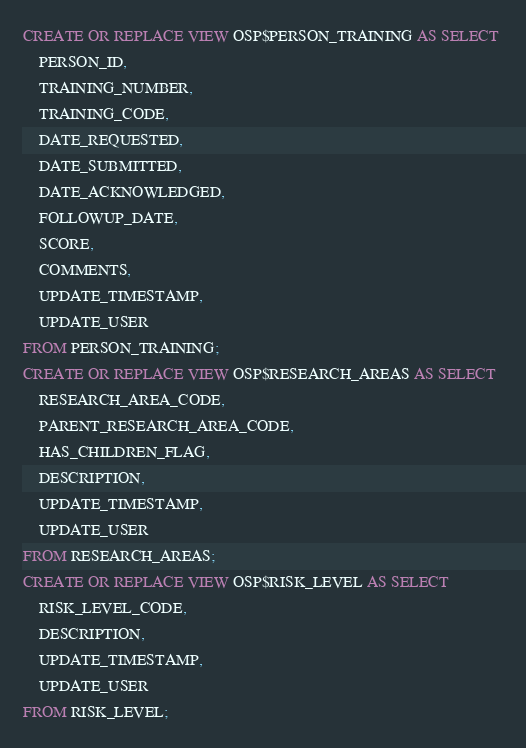Convert code to text. <code><loc_0><loc_0><loc_500><loc_500><_SQL_>CREATE OR REPLACE VIEW OSP$PERSON_TRAINING AS SELECT 
	PERSON_ID, 
	TRAINING_NUMBER, 
	TRAINING_CODE, 
	DATE_REQUESTED, 
	DATE_SUBMITTED, 
	DATE_ACKNOWLEDGED, 
	FOLLOWUP_DATE, 
	SCORE, 
	COMMENTS, 
	UPDATE_TIMESTAMP, 
	UPDATE_USER
FROM PERSON_TRAINING;
CREATE OR REPLACE VIEW OSP$RESEARCH_AREAS AS SELECT 
	RESEARCH_AREA_CODE, 
	PARENT_RESEARCH_AREA_CODE, 
	HAS_CHILDREN_FLAG, 
	DESCRIPTION, 
	UPDATE_TIMESTAMP, 
	UPDATE_USER
FROM RESEARCH_AREAS;
CREATE OR REPLACE VIEW OSP$RISK_LEVEL AS SELECT 
	RISK_LEVEL_CODE, 
	DESCRIPTION, 
	UPDATE_TIMESTAMP, 
	UPDATE_USER
FROM RISK_LEVEL;</code> 